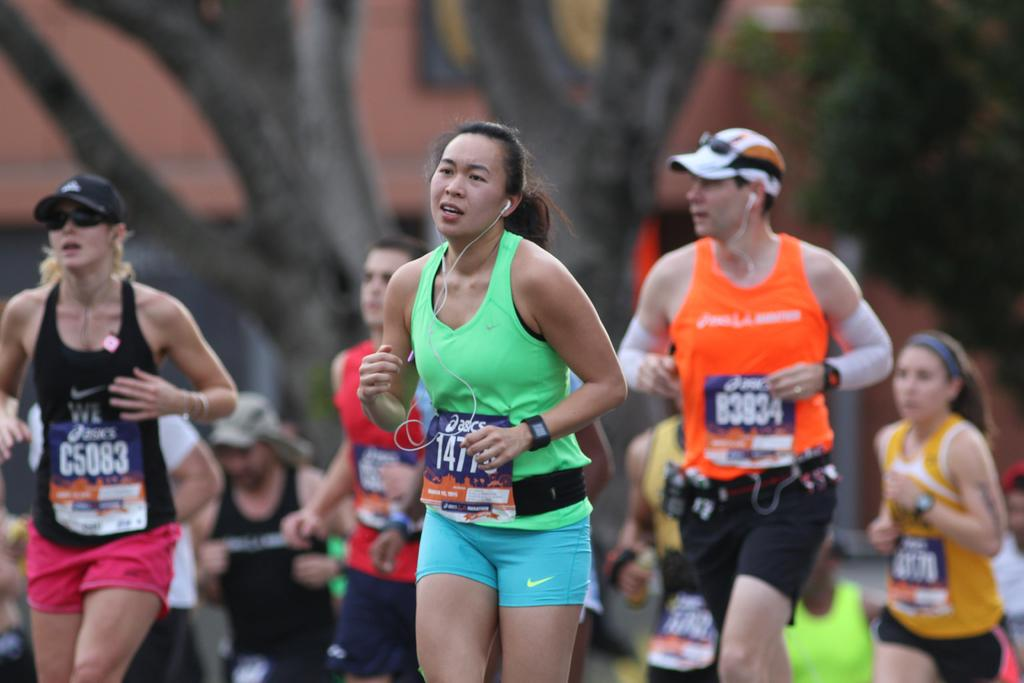What are the people in the image doing? The people in the image are running. What can be seen in the background of the image? There are trees and a building in the background of the image. How many persons in the image are wearing caps? Two persons in the image are wearing caps. What type of bell can be heard ringing in the image? There is no bell present or audible in the image; it only shows people running. 